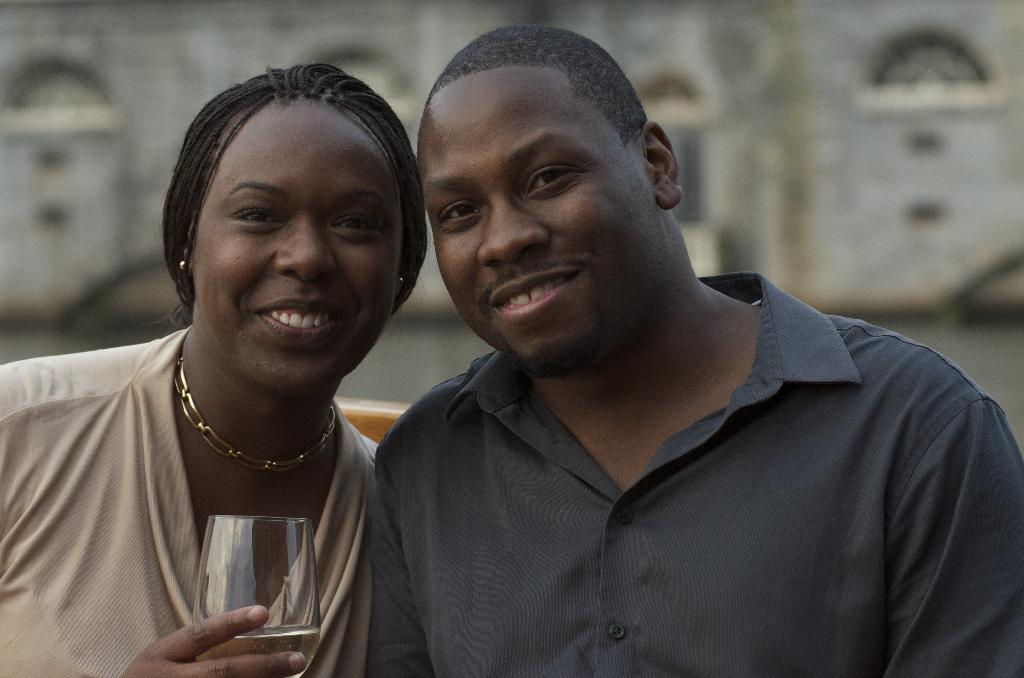What are the two people in the image doing? The boy and girl in the image are both smiling. What is the girl holding in the image? The girl is holding a glass of drink. Can you describe the expressions on the faces of the boy and girl? Both the boy and girl are smiling in the image. How would you describe the background of the image? The background of the image is blurred. What type of jam is being spread on the sponge in the image? There is no sponge or jam present in the image. Can you describe the ear of the boy in the image? There is no mention of an ear or any focus on a specific body part in the image. 